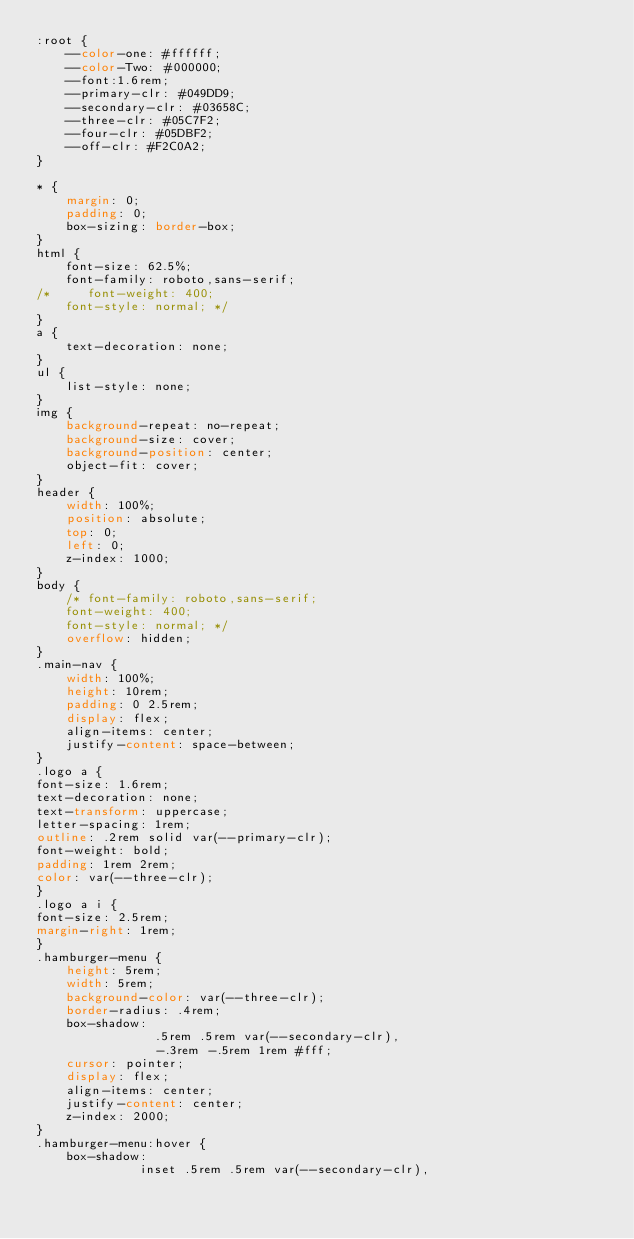Convert code to text. <code><loc_0><loc_0><loc_500><loc_500><_CSS_>:root {
    --color-one: #ffffff; 
    --color-Two: #000000; 
    --font:1.6rem;
    --primary-clr: #049DD9;
    --secondary-clr: #03658C;
    --three-clr: #05C7F2;
    --four-clr: #05DBF2; 
    --off-clr: #F2C0A2;
}

* {
    margin: 0;
    padding: 0;
    box-sizing: border-box;
}
html {
    font-size: 62.5%;
    font-family: roboto,sans-serif;
/*     font-weight: 400;
    font-style: normal; */
}
a {
    text-decoration: none;
}
ul {
    list-style: none;
}
img {
    background-repeat: no-repeat;
    background-size: cover;
    background-position: center;
    object-fit: cover;
}
header {
    width: 100%;
    position: absolute;
    top: 0;
    left: 0;
    z-index: 1000;
}
body {
    /* font-family: roboto,sans-serif;
    font-weight: 400;
    font-style: normal; */
    overflow: hidden;
}
.main-nav {
    width: 100%;
    height: 10rem;
    padding: 0 2.5rem;
    display: flex;
    align-items: center;
    justify-content: space-between;
}
.logo a {
font-size: 1.6rem;
text-decoration: none;
text-transform: uppercase;
letter-spacing: 1rem;
outline: .2rem solid var(--primary-clr);
font-weight: bold;
padding: 1rem 2rem;
color: var(--three-clr);
}
.logo a i {
font-size: 2.5rem;
margin-right: 1rem;
}
.hamburger-menu {
    height: 5rem;
    width: 5rem;
    background-color: var(--three-clr);
    border-radius: .4rem;
    box-shadow: 
                .5rem .5rem var(--secondary-clr),
                -.3rem -.5rem 1rem #fff;
    cursor: pointer;
    display: flex;
    align-items: center;
    justify-content: center;
    z-index: 2000;
}
.hamburger-menu:hover {
    box-shadow: 
              inset .5rem .5rem var(--secondary-clr),</code> 